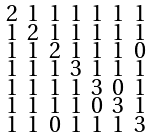<formula> <loc_0><loc_0><loc_500><loc_500>\begin{smallmatrix} 2 & 1 & 1 & 1 & 1 & 1 & 1 \\ 1 & 2 & 1 & 1 & 1 & 1 & 1 \\ 1 & 1 & 2 & 1 & 1 & 1 & 0 \\ 1 & 1 & 1 & 3 & 1 & 1 & 1 \\ 1 & 1 & 1 & 1 & 3 & 0 & 1 \\ 1 & 1 & 1 & 1 & 0 & 3 & 1 \\ 1 & 1 & 0 & 1 & 1 & 1 & 3 \end{smallmatrix}</formula> 